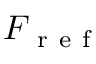Convert formula to latex. <formula><loc_0><loc_0><loc_500><loc_500>F _ { r e f }</formula> 